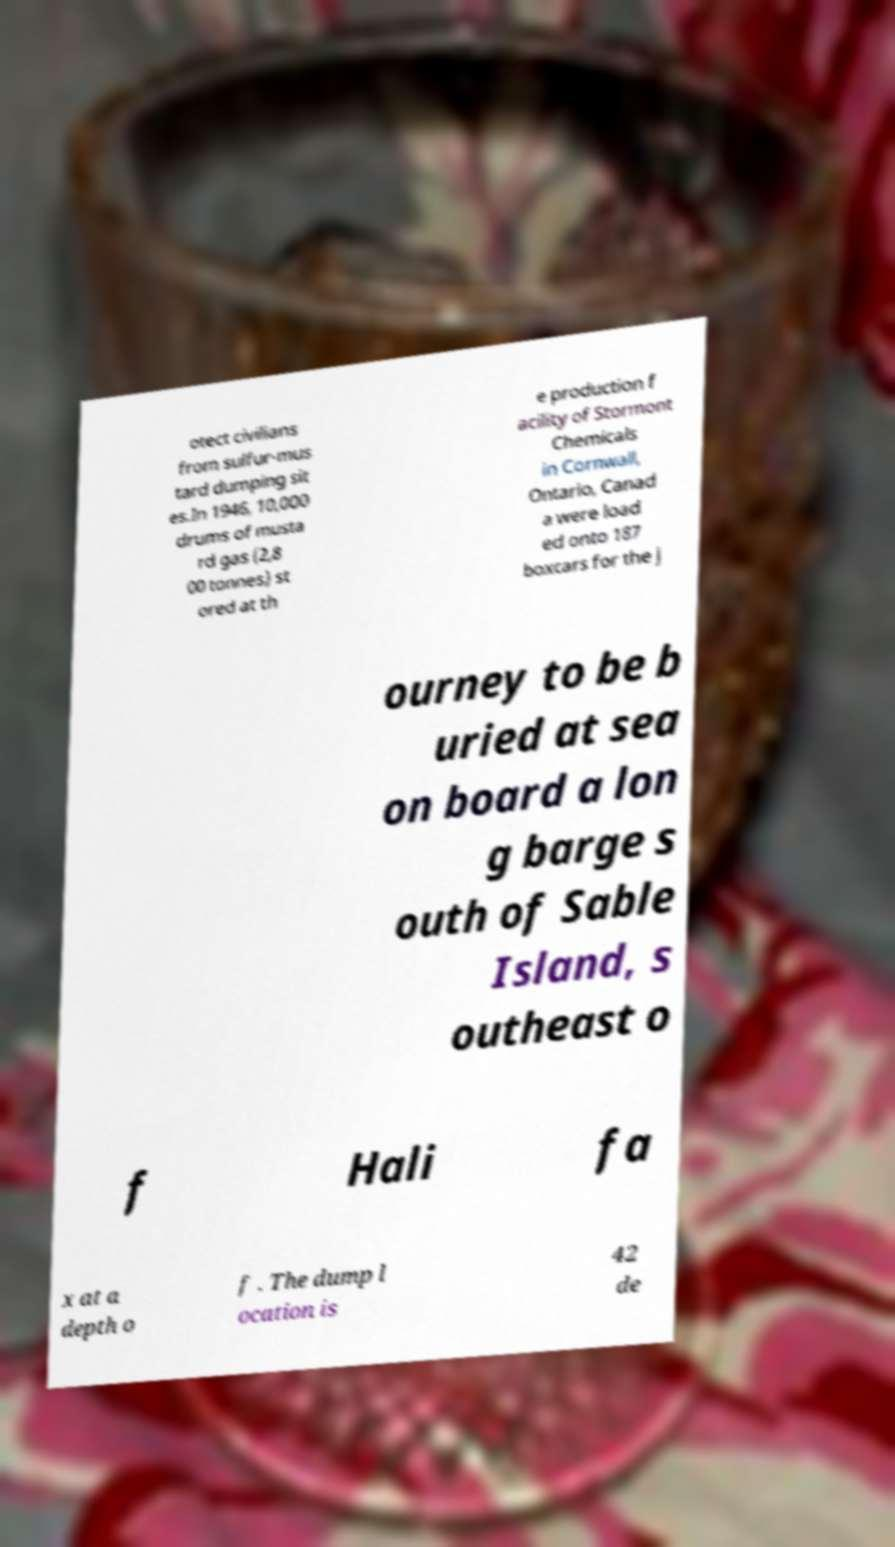Could you extract and type out the text from this image? otect civilians from sulfur-mus tard dumping sit es.In 1946, 10,000 drums of musta rd gas (2,8 00 tonnes) st ored at th e production f acility of Stormont Chemicals in Cornwall, Ontario, Canad a were load ed onto 187 boxcars for the j ourney to be b uried at sea on board a lon g barge s outh of Sable Island, s outheast o f Hali fa x at a depth o f . The dump l ocation is 42 de 